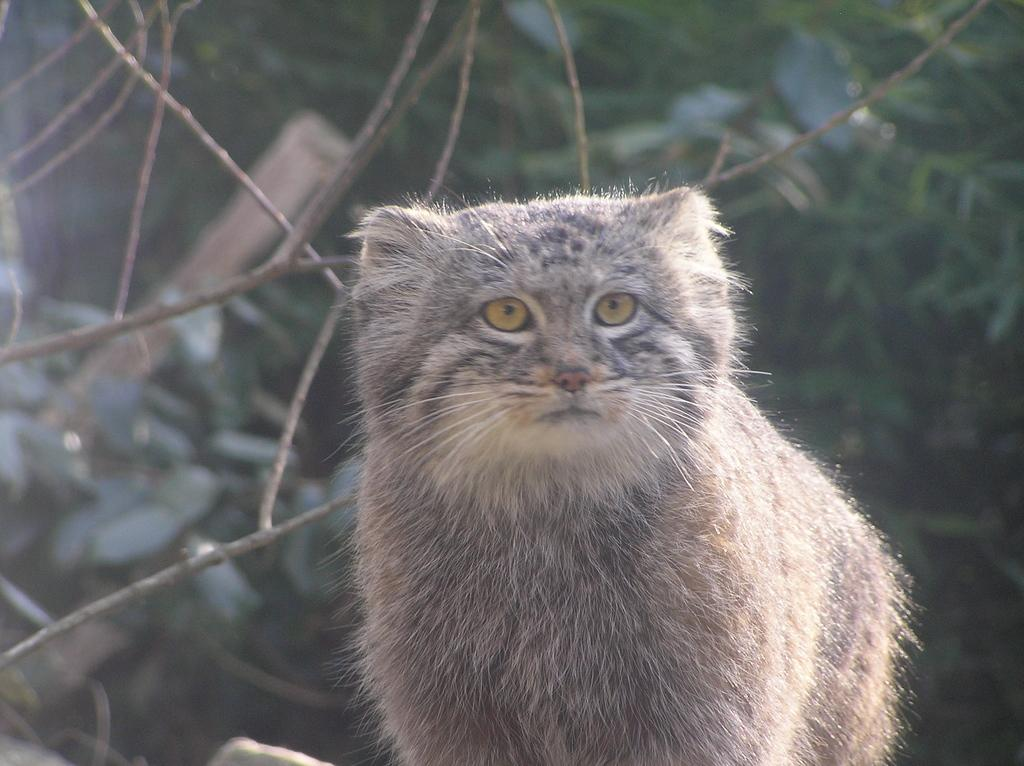What type of animal is in the image? There is a cat in the image. What can be seen in the background of the image? There are trees visible in the background of the image. What type of place is the cat standing on in the image? The image does not provide information about the type of place the cat is standing on. Is there a board visible in the image? There is no board present in the image. 